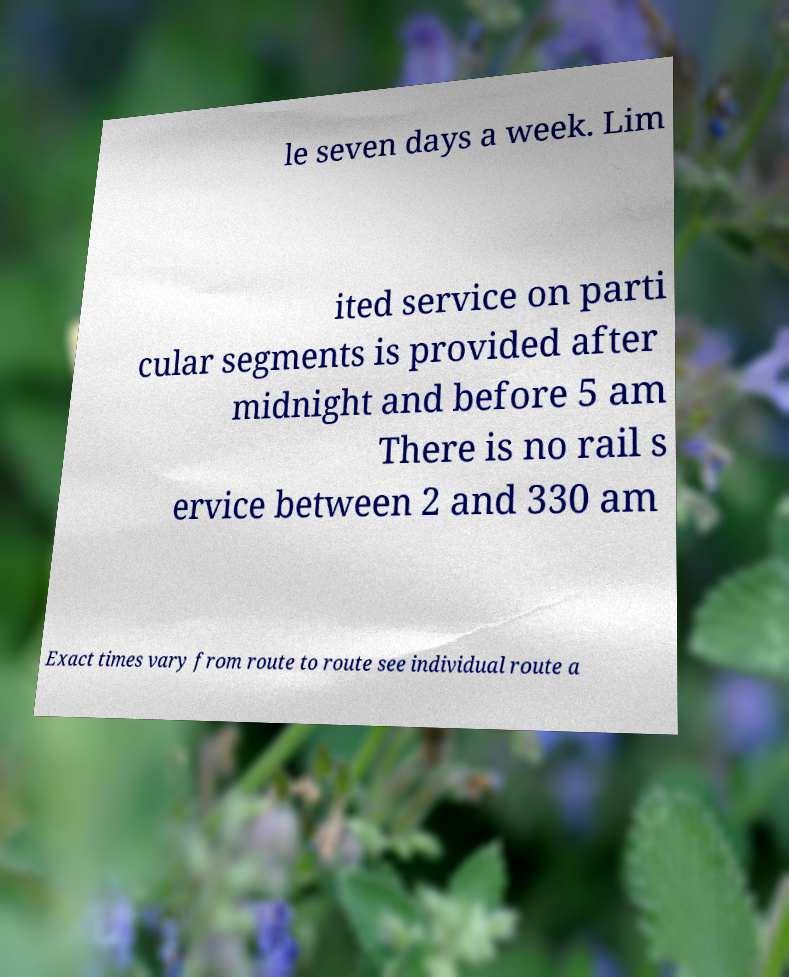Could you assist in decoding the text presented in this image and type it out clearly? le seven days a week. Lim ited service on parti cular segments is provided after midnight and before 5 am There is no rail s ervice between 2 and 330 am Exact times vary from route to route see individual route a 